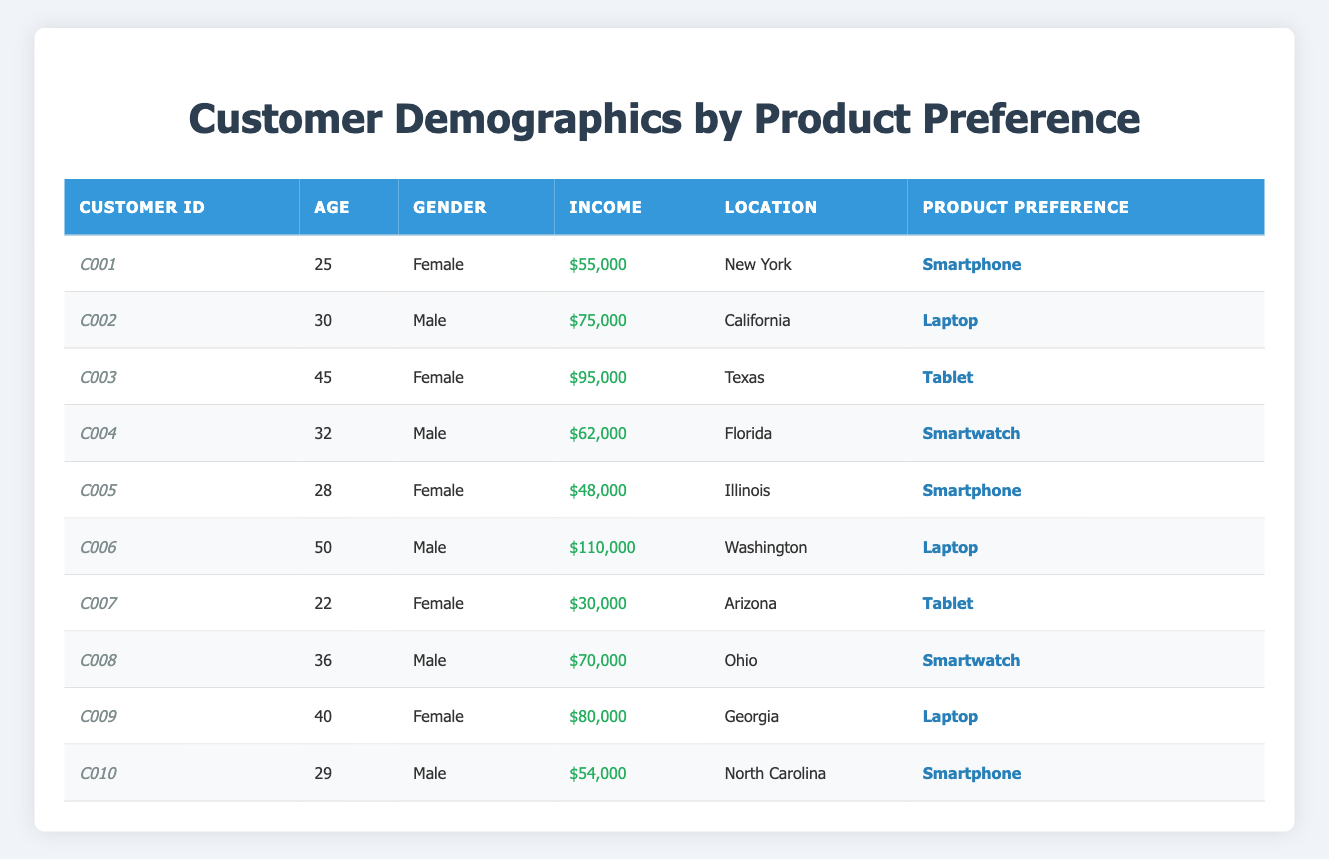What is the Product Preference of Customer C003? By looking at the row for Customer C003, the Product Preference listed is Tablet.
Answer: Tablet How many customers prefer Smartphones? From the table, Customers C001, C005, and C010 all prefer Smartphones. This gives us a total of 3 customers.
Answer: 3 What is the average age of customers who prefer Laptops? The ages of customers who prefer Laptops are 30 (C002), 50 (C006), and 40 (C009). The sum of these ages is 30 + 50 + 40 = 120, and there are 3 customers, so the average age is 120 / 3 = 40.
Answer: 40 What is the income of Customer C008? The income for Customer C008, as listed in the table, is $70,000.
Answer: $70,000 Is there any female customer who prefers a Smartwatch? By reviewing the table, Customers C004 and C008 are males while there are no females listed who prefer Smartwatch, so the answer is no.
Answer: No Which location has the highest income customer? Customer C006 has the highest income of $110,000, and is located in Washington.
Answer: Washington What is the total income of all customers who prefer Tablets? The customers with Tablet preference are C003 with $95,000 and C007 with $30,000. The total income is $95,000 + $30,000 = $125,000.
Answer: $125,000 How many male customers are there in total? From the table, looking at the gender column, the male customers are C002, C004, C006, C008, and C010, adding up to 5 male customers.
Answer: 5 Which product preference is the most common amongst female customers? Female customers C001, C003, C005, and C009 prefer Smartphones, Tablets, Smartphones, and Laptops respectively. The most common preference is Smartphones (2 out of 4).
Answer: Smartphones What is the median income of customers who prefer Smartwatches? The incomes of customers C004 and C008 who prefer Smartwatches are $62,000 and $70,000 respectively. The median income is the average of these two values: ($62,000 + $70,000) / 2 = $66,000.
Answer: $66,000 